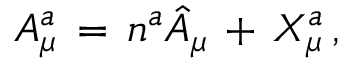Convert formula to latex. <formula><loc_0><loc_0><loc_500><loc_500>A _ { \mu } ^ { a } \, = \, n ^ { a } \hat { A } _ { \mu } \, + \, X _ { \mu } ^ { a } \, ,</formula> 